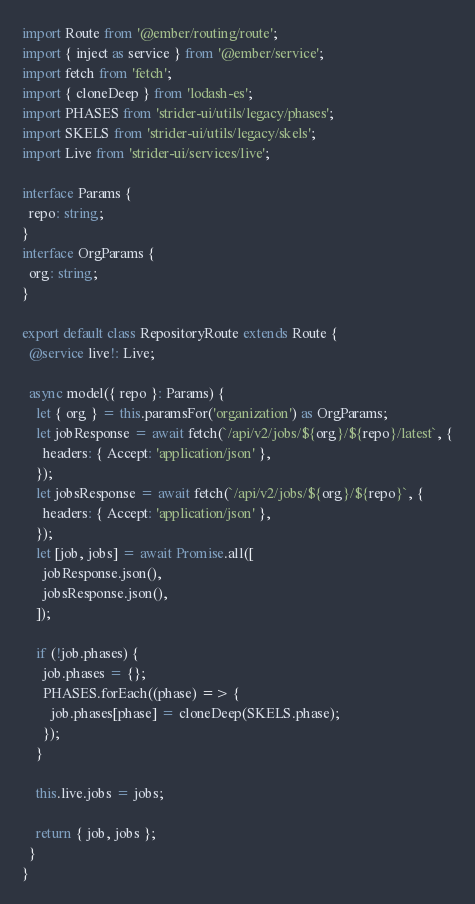Convert code to text. <code><loc_0><loc_0><loc_500><loc_500><_TypeScript_>import Route from '@ember/routing/route';
import { inject as service } from '@ember/service';
import fetch from 'fetch';
import { cloneDeep } from 'lodash-es';
import PHASES from 'strider-ui/utils/legacy/phases';
import SKELS from 'strider-ui/utils/legacy/skels';
import Live from 'strider-ui/services/live';

interface Params {
  repo: string;
}
interface OrgParams {
  org: string;
}

export default class RepositoryRoute extends Route {
  @service live!: Live;

  async model({ repo }: Params) {
    let { org } = this.paramsFor('organization') as OrgParams;
    let jobResponse = await fetch(`/api/v2/jobs/${org}/${repo}/latest`, {
      headers: { Accept: 'application/json' },
    });
    let jobsResponse = await fetch(`/api/v2/jobs/${org}/${repo}`, {
      headers: { Accept: 'application/json' },
    });
    let [job, jobs] = await Promise.all([
      jobResponse.json(),
      jobsResponse.json(),
    ]);

    if (!job.phases) {
      job.phases = {};
      PHASES.forEach((phase) => {
        job.phases[phase] = cloneDeep(SKELS.phase);
      });
    }

    this.live.jobs = jobs;

    return { job, jobs };
  }
}
</code> 